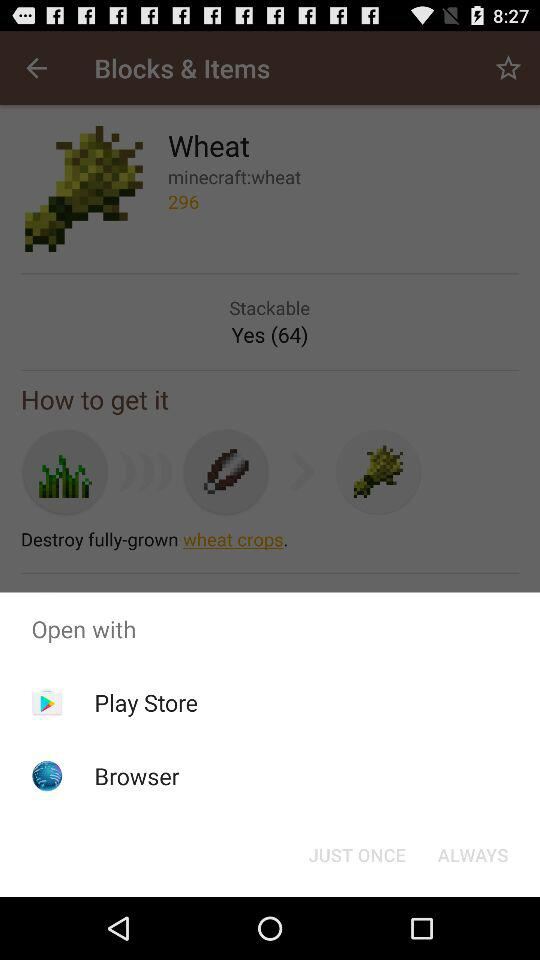How many items can be stacked?
Answer the question using a single word or phrase. 64 